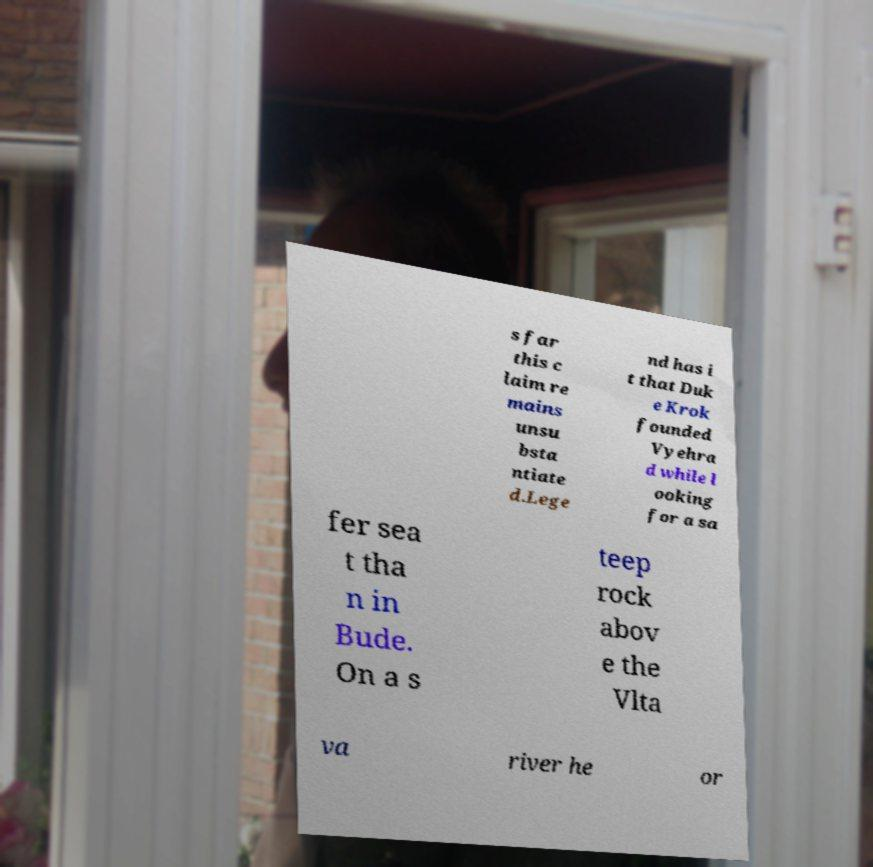Could you extract and type out the text from this image? s far this c laim re mains unsu bsta ntiate d.Lege nd has i t that Duk e Krok founded Vyehra d while l ooking for a sa fer sea t tha n in Bude. On a s teep rock abov e the Vlta va river he or 